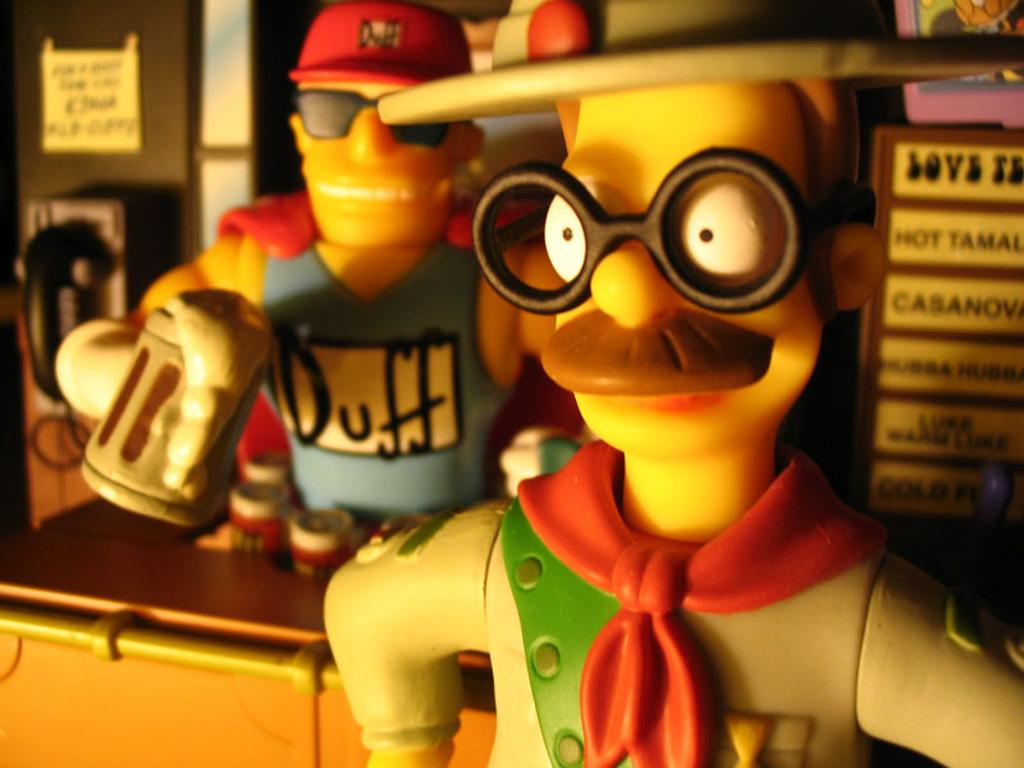What type of objects can be seen in the image? There are toys in the image. Can you describe the appearance of the toys? The toys are in different colors. What else is present on the table in the image? There are objects on the table in the image. What communication device is visible in the image? There is a telephone visible in the image. How many trees can be seen in the image? There are no trees visible in the image. What type of test is being conducted in the image? There is no test being conducted in the image. 